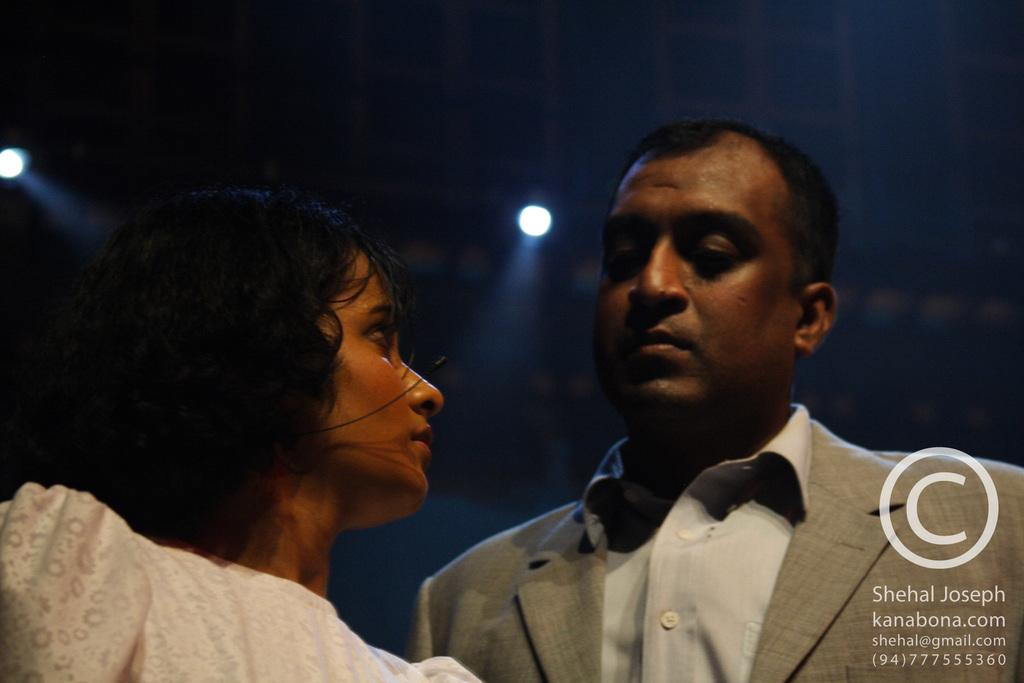How many people are in the image? There are two people in the image. What is the attire of the first person? The first person is wearing an ash-colored blazer and a white shirt. What is the attire of the second person? The second person is wearing a white-colored dress. What can be seen in the background of the image? There are lights visible in the background of the image. What type of cabbage is being used as a disguise by the spy in the image? There is no spy or cabbage present in the image. What type of airport can be seen in the background of the image? There is no airport visible in the background of the image; only lights are present. 